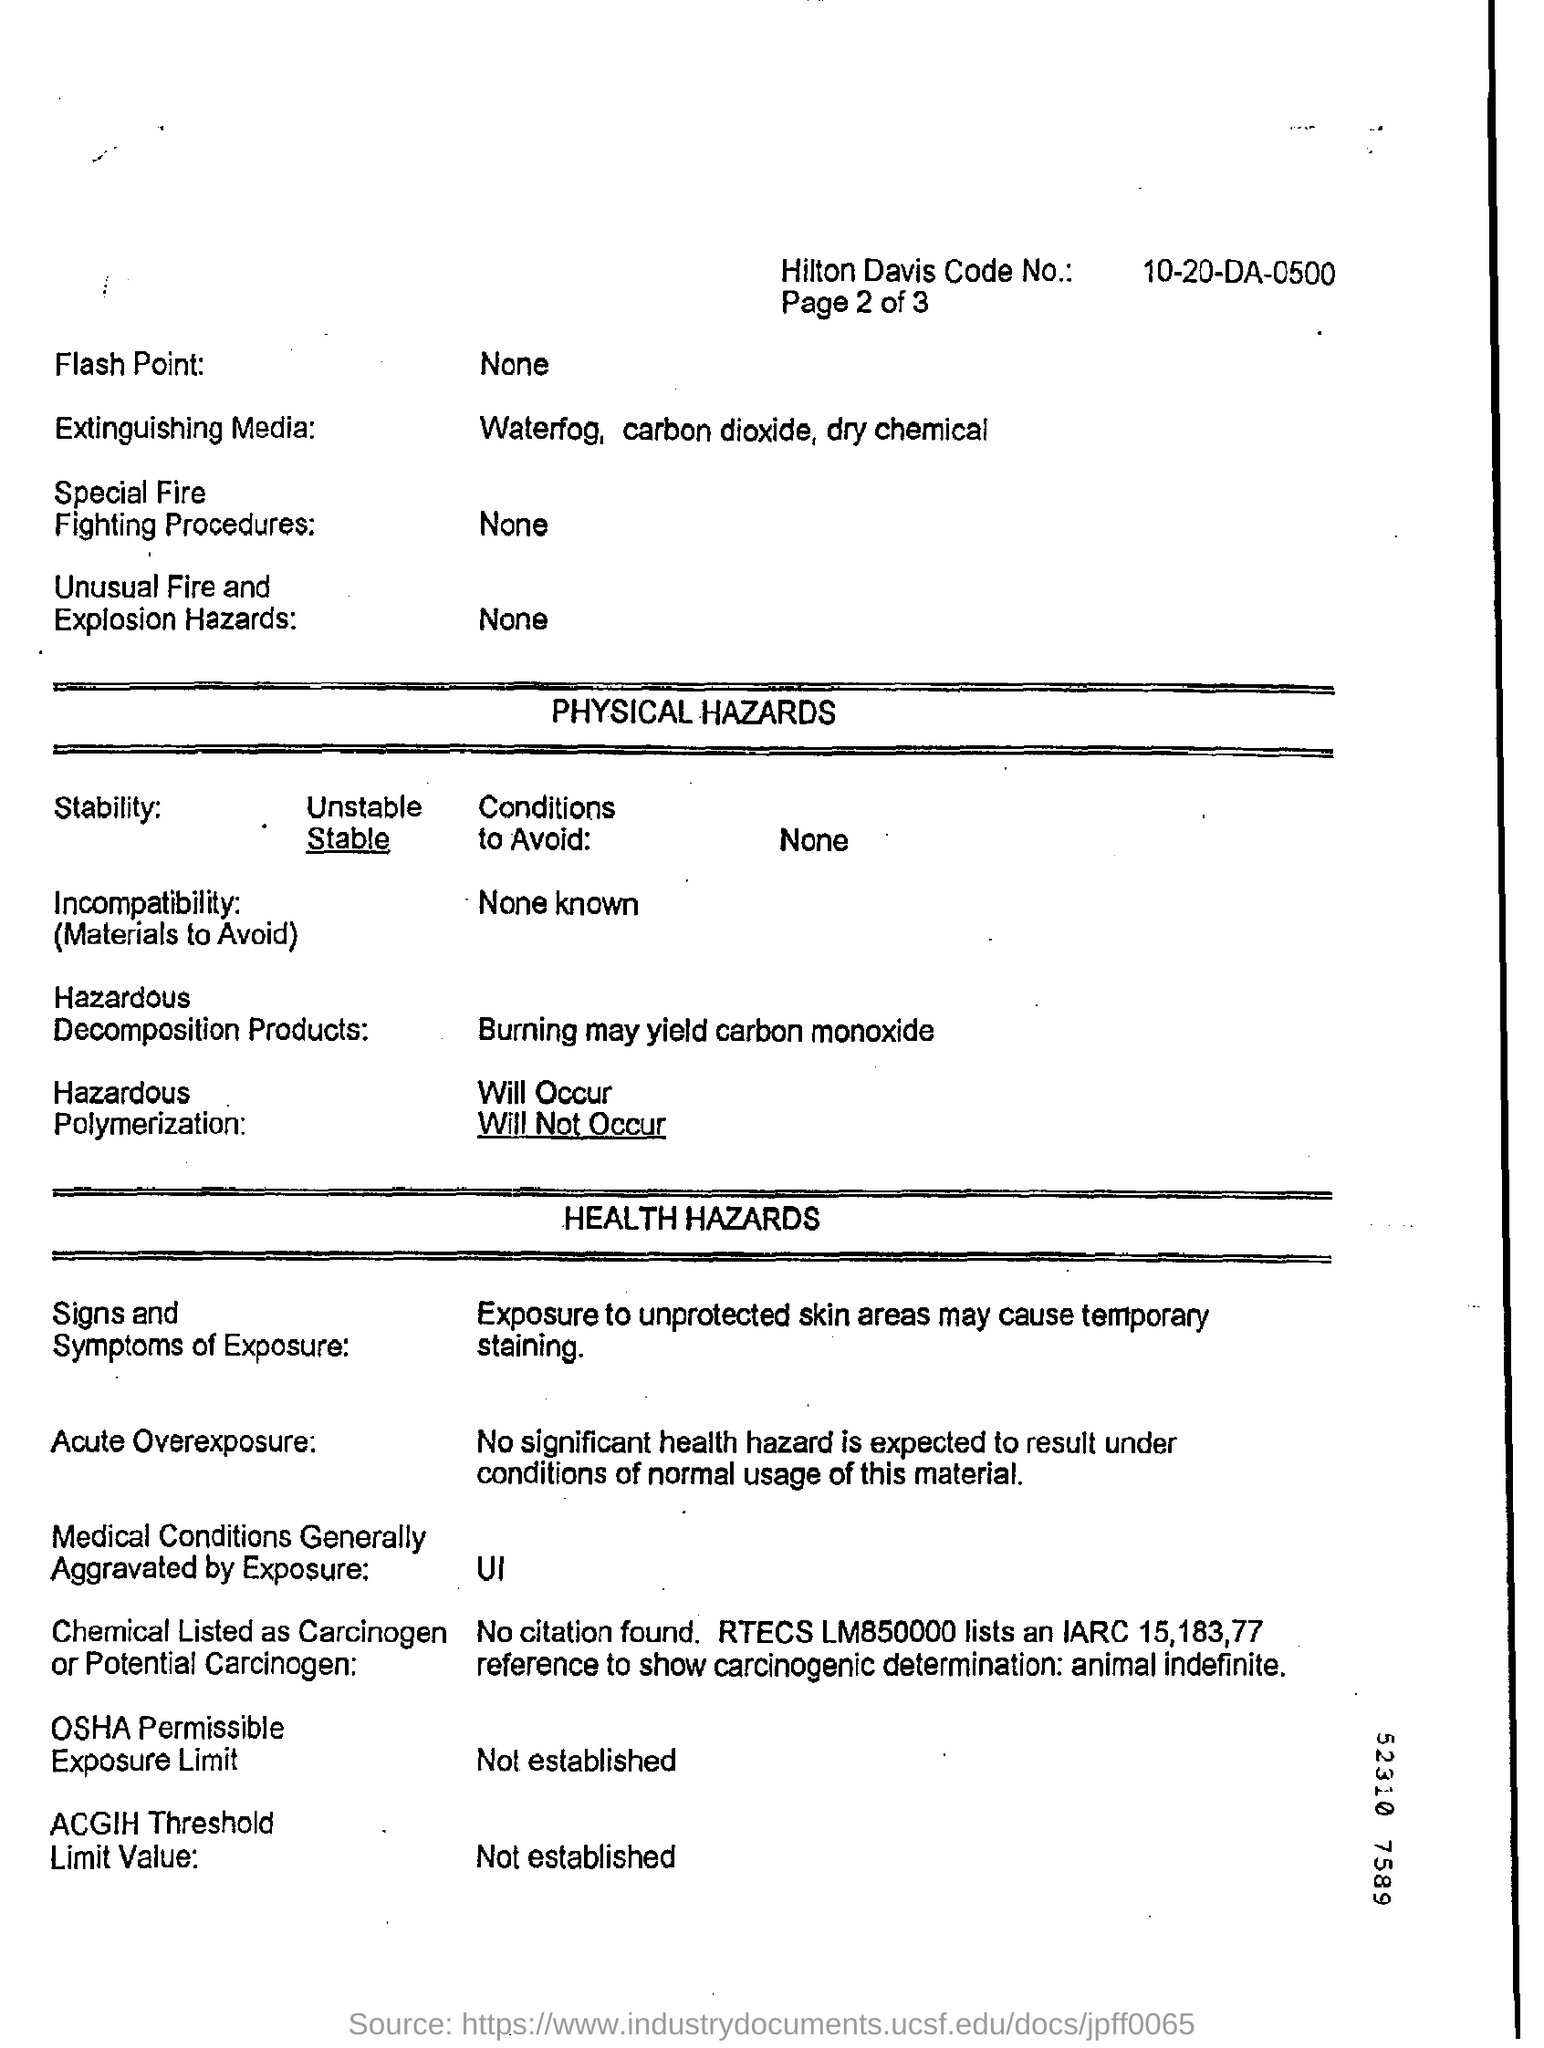Specify some key components in this picture. The polymerization of hazardous materials will not occur. The extinguishing media in question is carbon dioxide. The Hilton Davis Code No. is 10-20-DA-0500. 